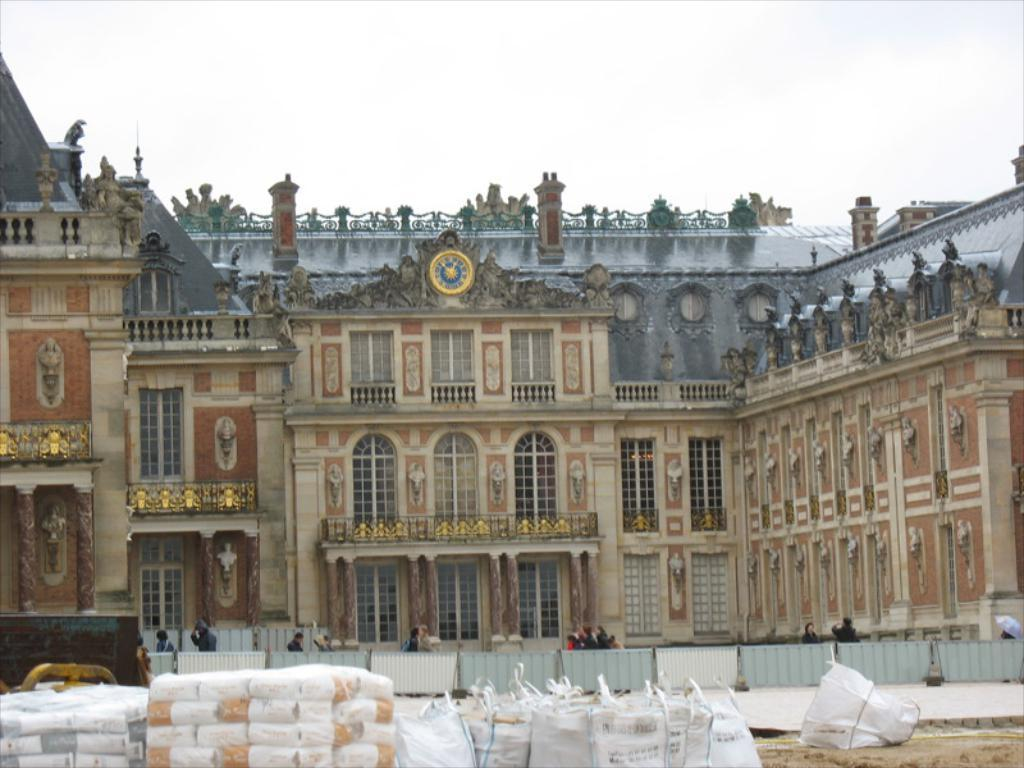What is the main structure visible in the image? There is a building in the image. Are there any living beings present in the image? Yes, there are people in the image. What else can be seen in front of the building? There are other objects in front of the building. How many legs can be seen on the sky in the image? The sky does not have legs, as it is a celestial body and not a living being. 